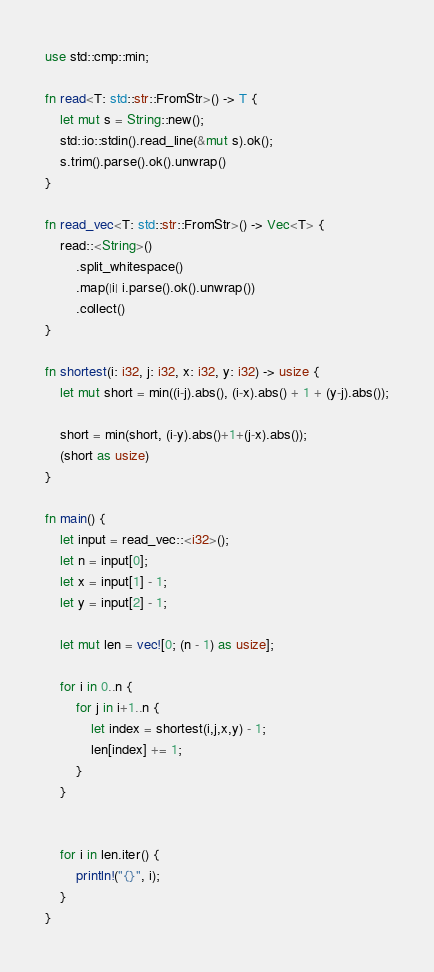Convert code to text. <code><loc_0><loc_0><loc_500><loc_500><_Rust_>use std::cmp::min;

fn read<T: std::str::FromStr>() -> T {
    let mut s = String::new();
    std::io::stdin().read_line(&mut s).ok();
    s.trim().parse().ok().unwrap()
}

fn read_vec<T: std::str::FromStr>() -> Vec<T> {
    read::<String>()
        .split_whitespace()
        .map(|i| i.parse().ok().unwrap())
        .collect()
}

fn shortest(i: i32, j: i32, x: i32, y: i32) -> usize {
    let mut short = min((i-j).abs(), (i-x).abs() + 1 + (y-j).abs());
    
    short = min(short, (i-y).abs()+1+(j-x).abs());
    (short as usize)
}

fn main() {
    let input = read_vec::<i32>();
    let n = input[0];
    let x = input[1] - 1;
    let y = input[2] - 1;

    let mut len = vec![0; (n - 1) as usize];

    for i in 0..n {
        for j in i+1..n {
            let index = shortest(i,j,x,y) - 1;
            len[index] += 1;
        }
    }


    for i in len.iter() {
        println!("{}", i);
    }
}</code> 